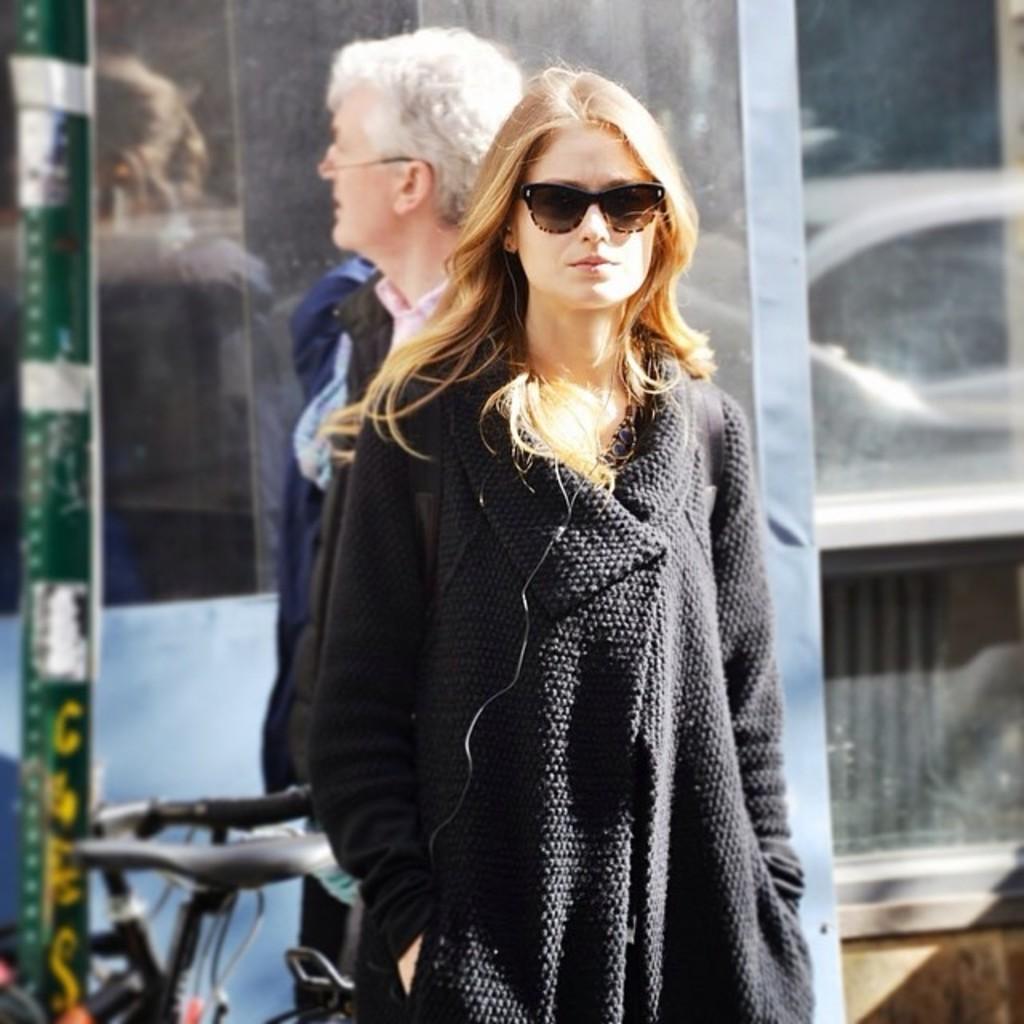In one or two sentences, can you explain what this image depicts? In the given image i can see a lady with spectacles and behind her i can see a person and bicycle. 